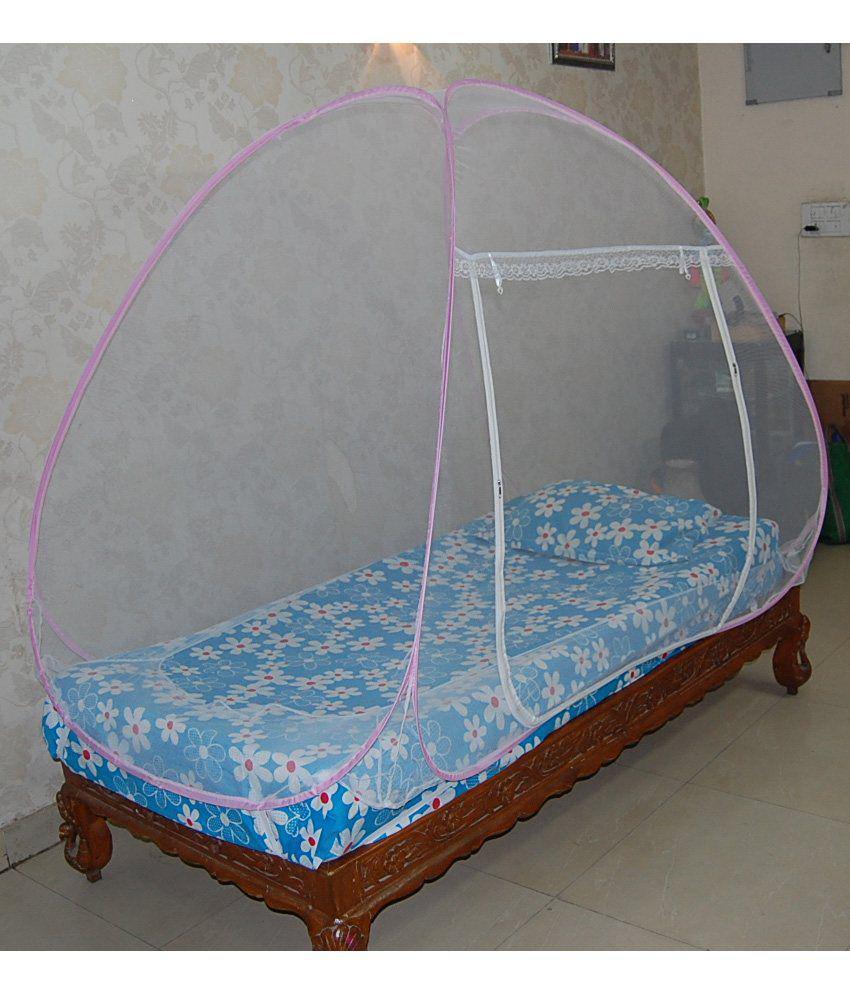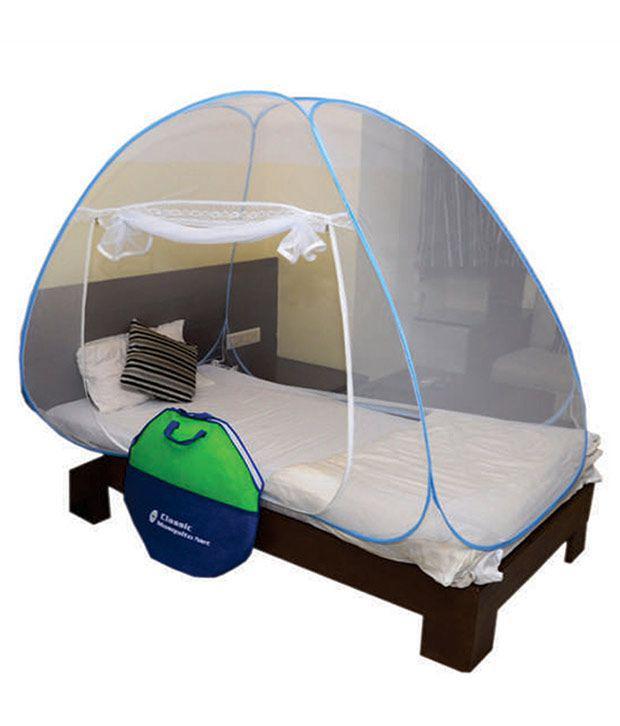The first image is the image on the left, the second image is the image on the right. Examine the images to the left and right. Is the description "One of the mattresses is blue and white." accurate? Answer yes or no. Yes. 